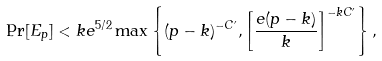<formula> <loc_0><loc_0><loc_500><loc_500>\Pr [ E _ { p } ] < k e ^ { 5 / 2 } \max \left \{ ( p - k ) ^ { - C ^ { \prime } } , \left [ \frac { e ( p - k ) } { k } \right ] ^ { - k C ^ { \prime } } \right \} ,</formula> 